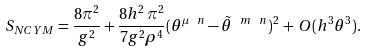Convert formula to latex. <formula><loc_0><loc_0><loc_500><loc_500>S _ { N C Y M } = \frac { 8 \pi ^ { 2 } } { g ^ { 2 } } + \frac { 8 h ^ { 2 } \, \pi ^ { 2 } } { 7 g ^ { 2 } \rho ^ { 4 } } ( \theta ^ { \mu \ n } - \tilde { \theta } ^ { \ m \ n } ) ^ { 2 } \, + \, O ( h ^ { 3 } \theta ^ { 3 } ) .</formula> 